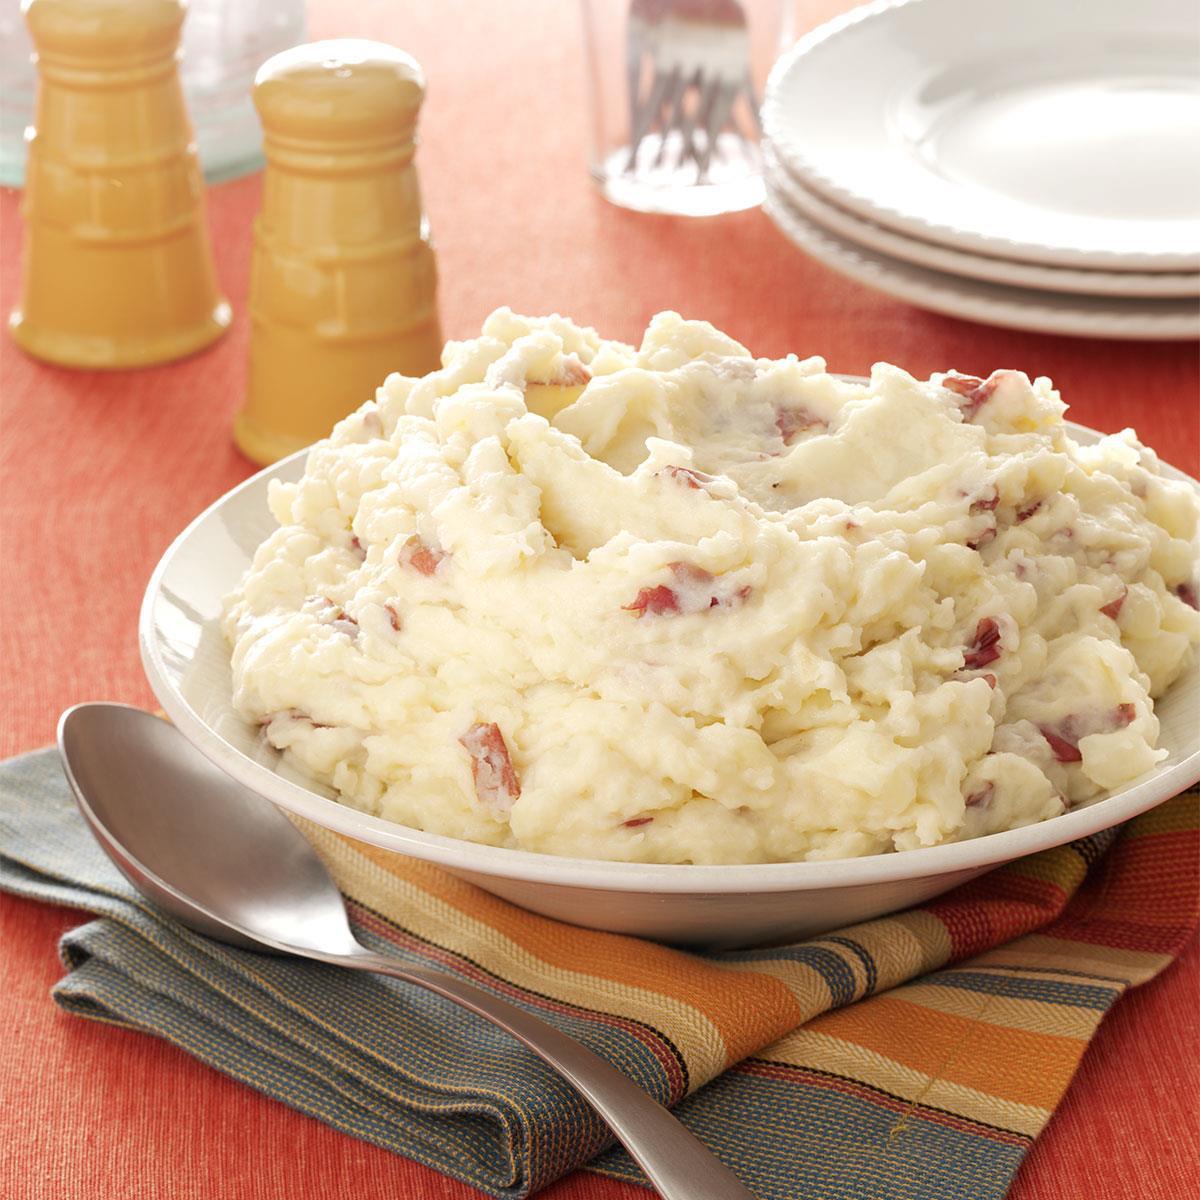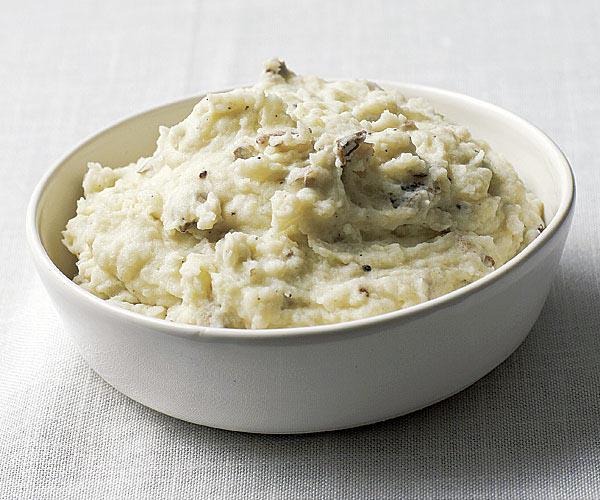The first image is the image on the left, the second image is the image on the right. Evaluate the accuracy of this statement regarding the images: "Silverware is shown near the bowl in one of the images.". Is it true? Answer yes or no. Yes. The first image is the image on the left, the second image is the image on the right. Evaluate the accuracy of this statement regarding the images: "An item of silverware is on a napkin that also holds a round white dish containing mashed potatoes.". Is it true? Answer yes or no. Yes. 